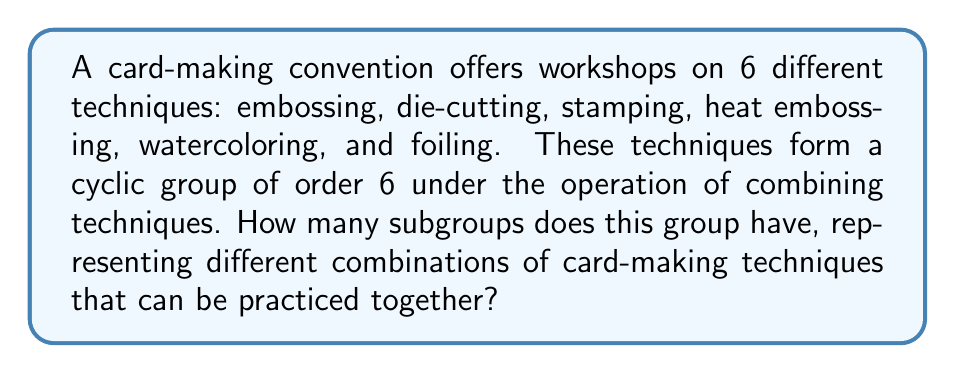What is the answer to this math problem? To solve this problem, we need to apply the properties of cyclic groups and their subgroups. Let's approach this step-by-step:

1) First, recall that a cyclic group of order 6 is isomorphic to $\mathbb{Z}_6$, the group of integers modulo 6.

2) In a cyclic group, the number of subgroups is equal to the number of divisors of the group's order. This is because each subgroup of a cyclic group is also cyclic, and its order must divide the order of the parent group.

3) The divisors of 6 are: 1, 2, 3, and 6.

4) Now, let's identify these subgroups:
   - The trivial subgroup $\{e\}$ of order 1
   - A subgroup of order 2: $\{e, a^3\}$, where $a$ is the generator of the group
   - A subgroup of order 3: $\{e, a^2, a^4\}$
   - The entire group of order 6: $\{e, a, a^2, a^3, a^4, a^5\}$

5) In terms of card-making techniques, these subgroups represent:
   - Trivial subgroup: No technique (just the identity)
   - Order 2 subgroup: A combination of three techniques that, when repeated, gives all six
   - Order 3 subgroup: A combination of two techniques that, when repeated thrice, gives all six
   - Order 6 subgroup: All six techniques

Therefore, there are 4 subgroups in total, each representing a different combination of card-making techniques that can be practiced together.
Answer: 4 subgroups 